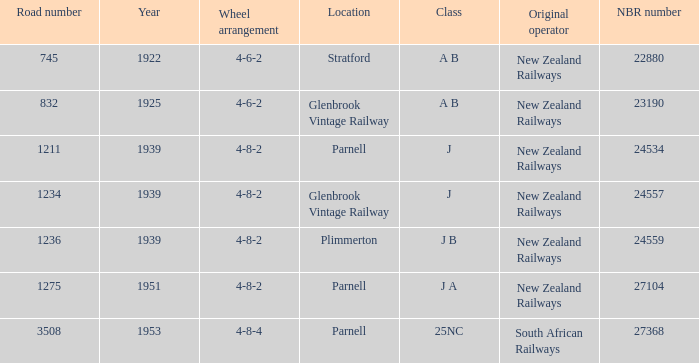Which class starts after 1939 and has a road number smaller than 3508? J A. 